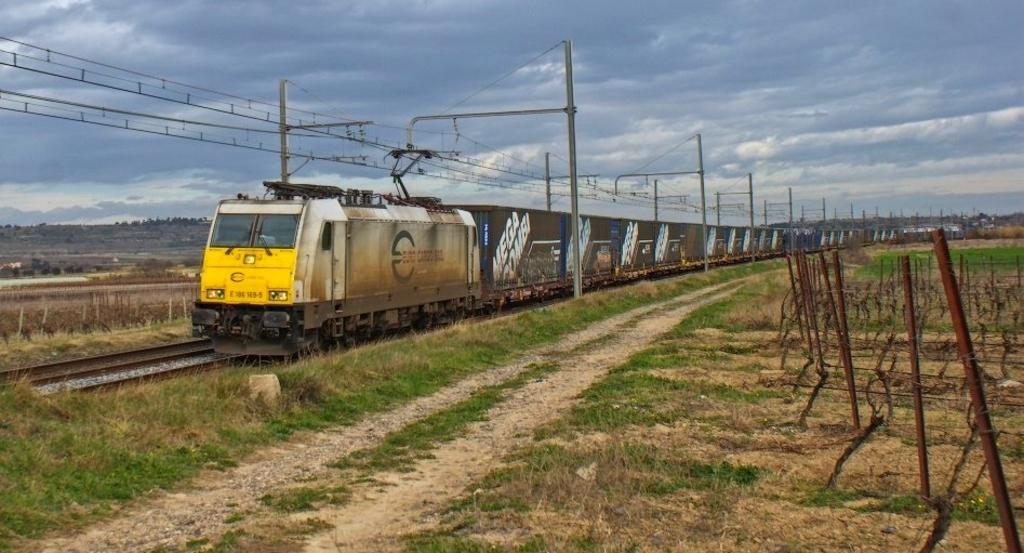What is the main subject of the image? The main subject of the image is a train. What is the train doing in the image? The train is moving on a railway track. What type of vegetation can be seen in the image? There is grass visible in the image. Can you describe any structures or objects in the image? There is an iron stand and poles with wires in the image. What can be seen in the background of the image? There are hills and a cloudy sky in the background of the image. What type of cheese is being cooked in the oven in the image? There is no cheese or oven present in the image; it features a train moving on a railway track. How many brothers are visible in the image? There are no people, let alone brothers, visible in the image. 